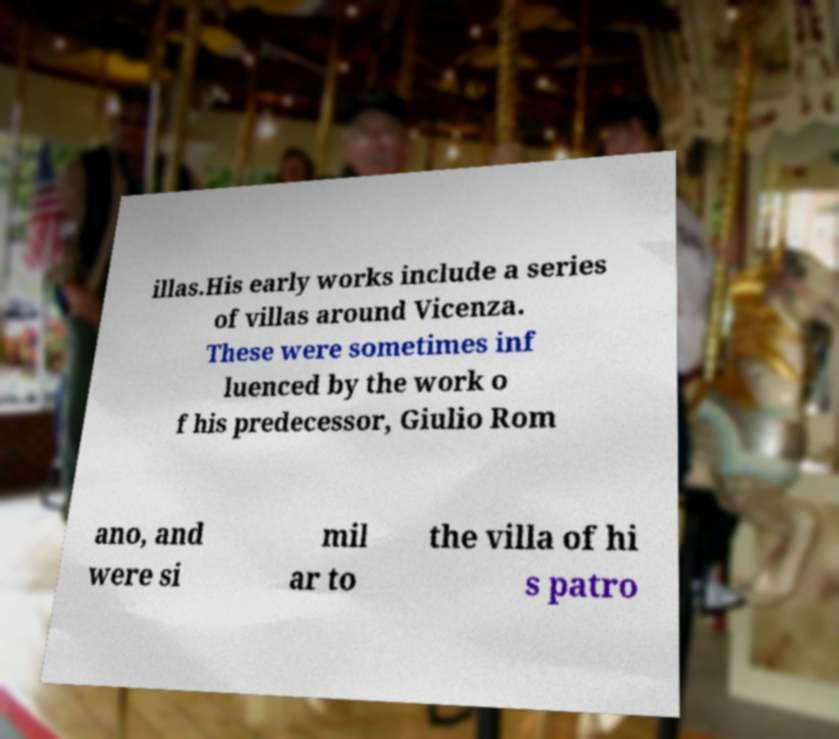For documentation purposes, I need the text within this image transcribed. Could you provide that? illas.His early works include a series of villas around Vicenza. These were sometimes inf luenced by the work o f his predecessor, Giulio Rom ano, and were si mil ar to the villa of hi s patro 